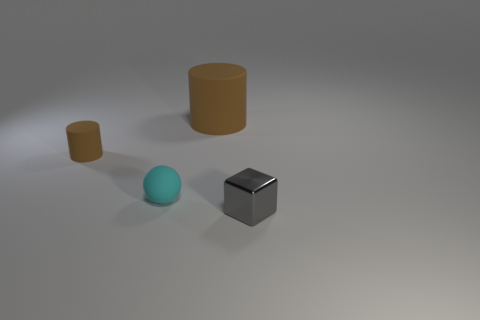Add 2 cyan things. How many objects exist? 6 Subtract all cubes. How many objects are left? 3 Subtract all gray objects. Subtract all brown matte spheres. How many objects are left? 3 Add 1 brown rubber cylinders. How many brown rubber cylinders are left? 3 Add 1 large brown cylinders. How many large brown cylinders exist? 2 Subtract 0 purple cylinders. How many objects are left? 4 